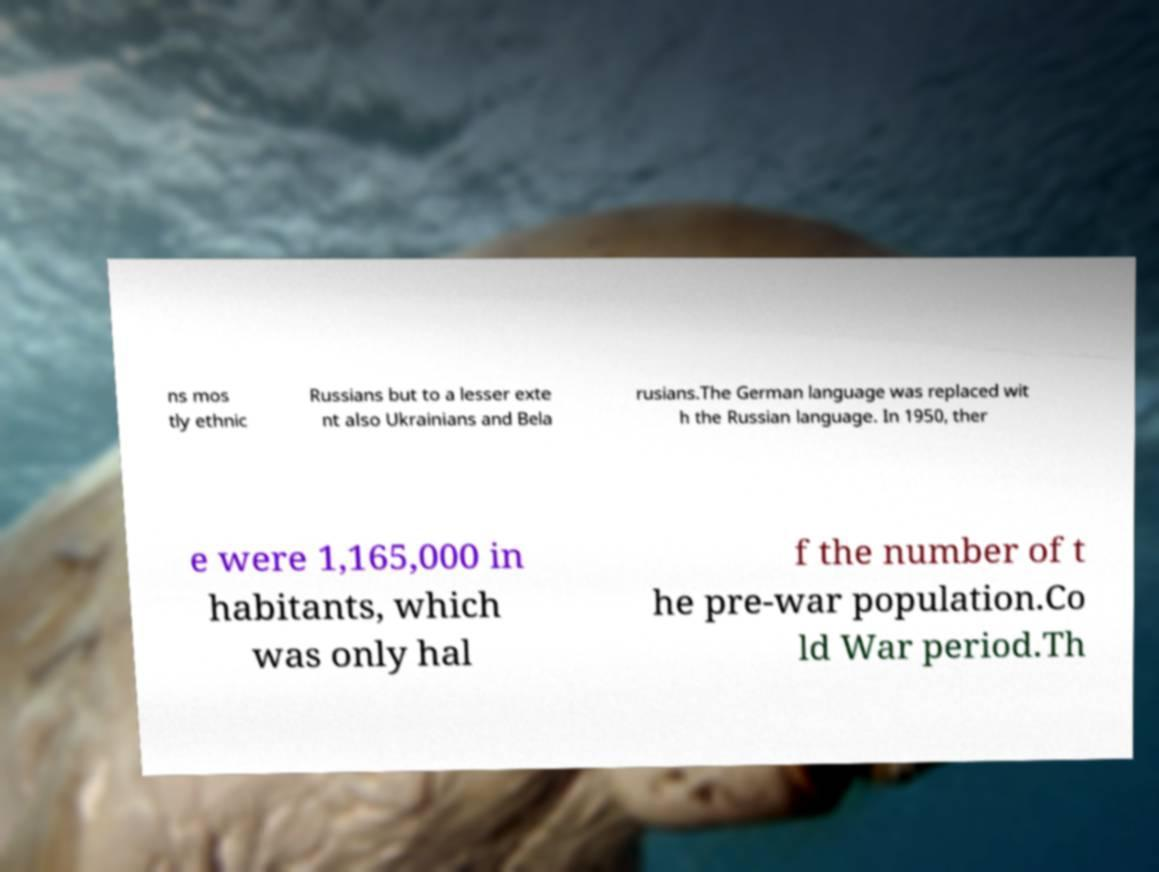For documentation purposes, I need the text within this image transcribed. Could you provide that? ns mos tly ethnic Russians but to a lesser exte nt also Ukrainians and Bela rusians.The German language was replaced wit h the Russian language. In 1950, ther e were 1,165,000 in habitants, which was only hal f the number of t he pre-war population.Co ld War period.Th 